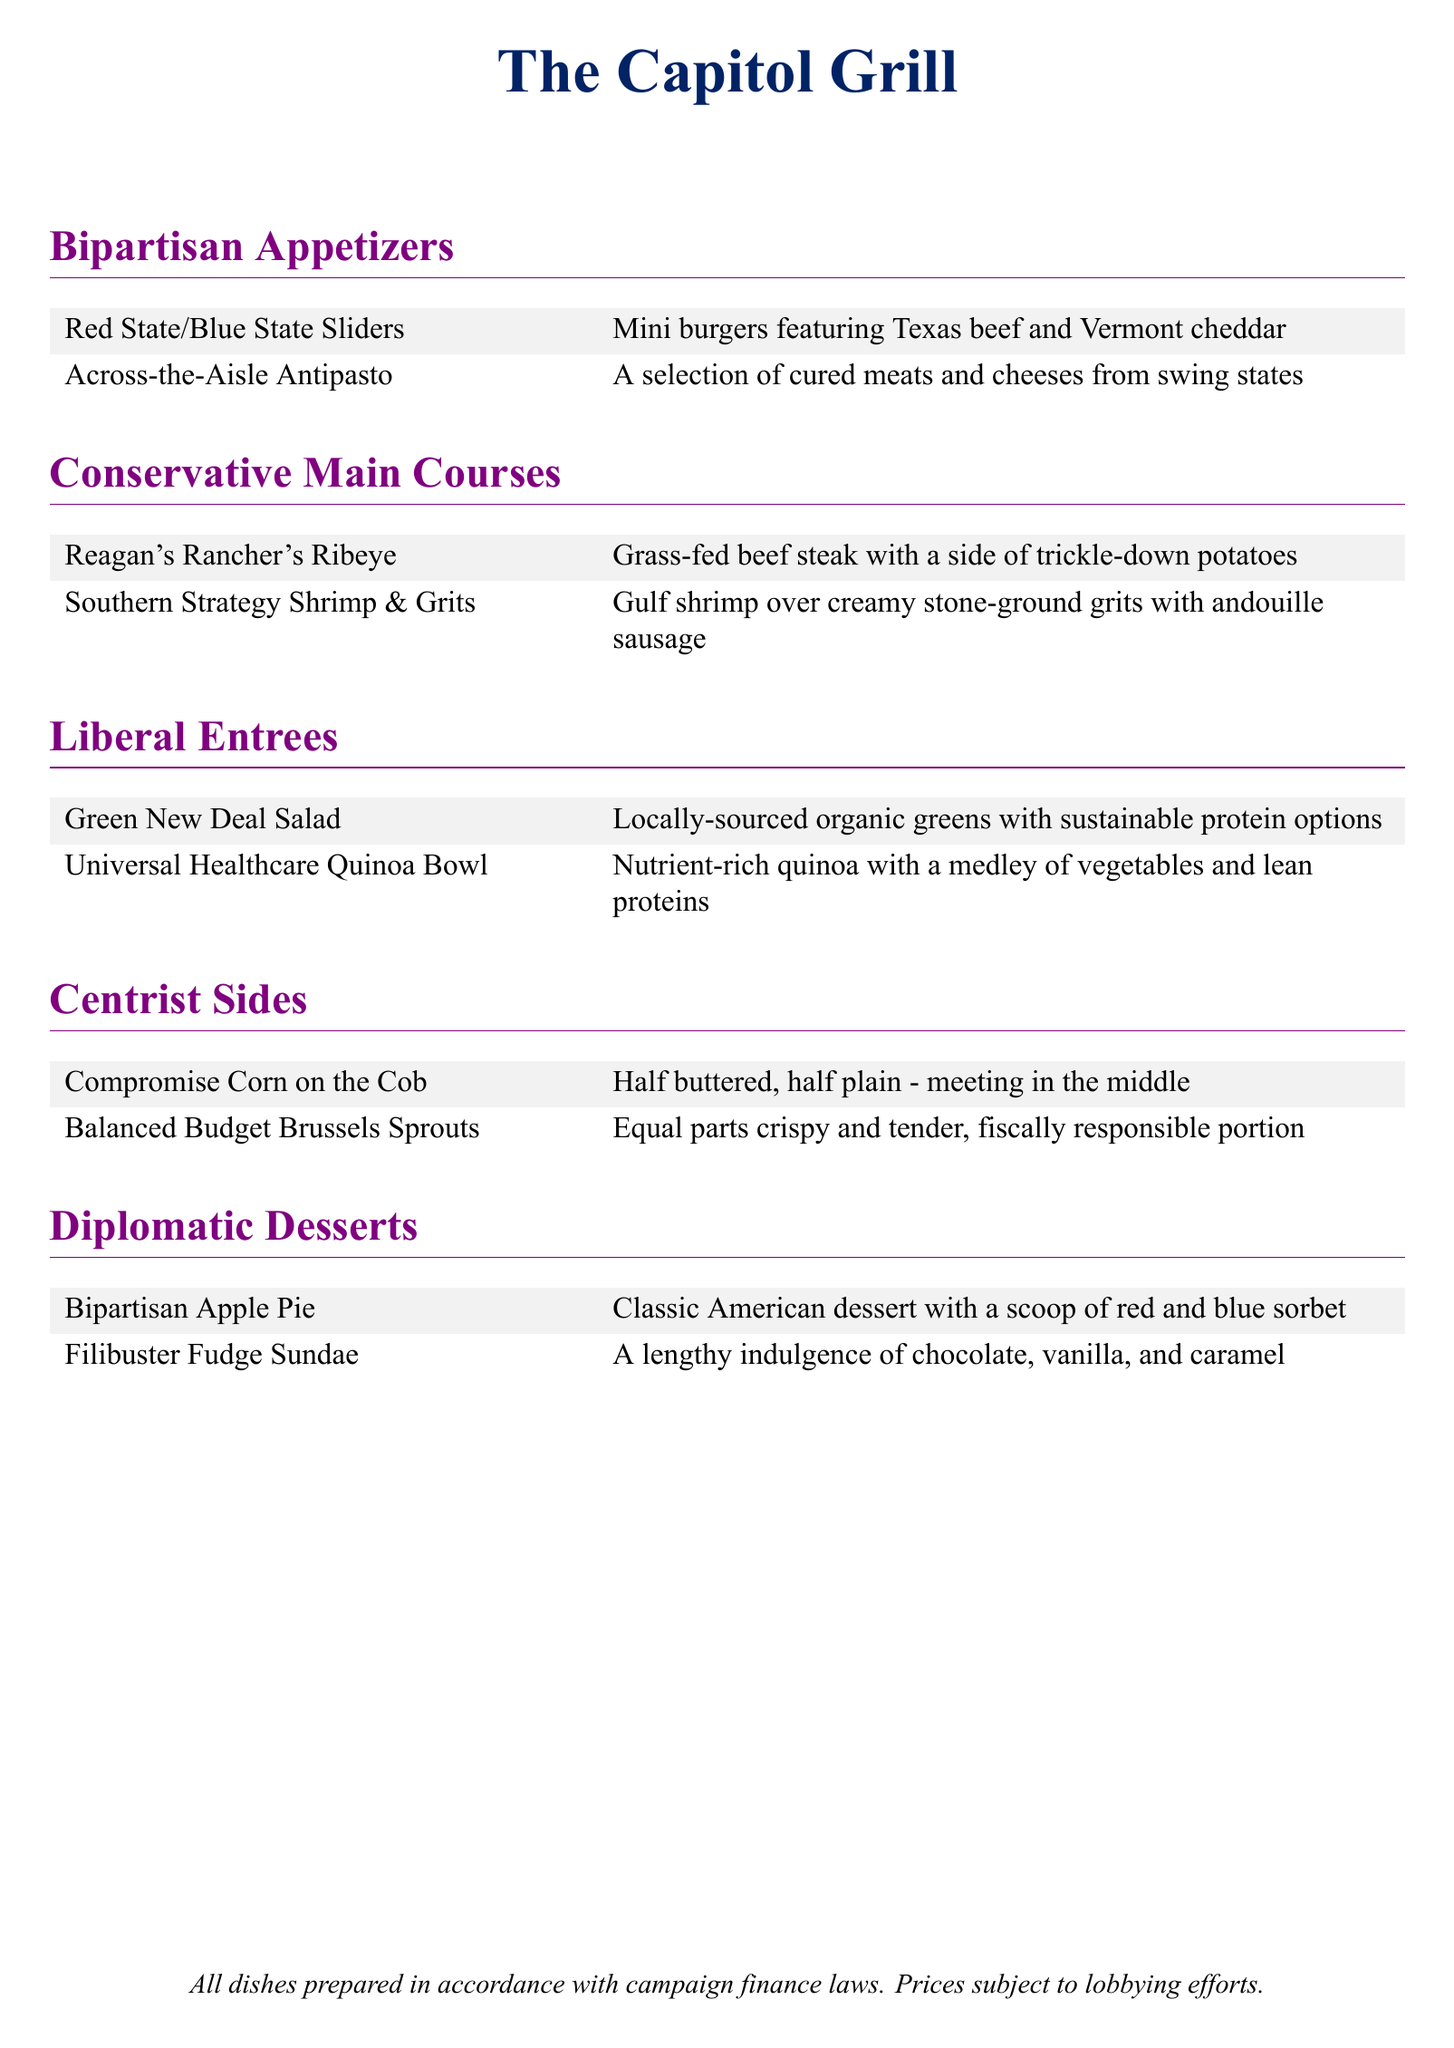What is the name of the restaurant? The name of the restaurant is prominently displayed at the top of the document.
Answer: The Capitol Grill What color represents conservatives in this menu? The document uses colors to distinguish political themes, with blue assigned to conservatives.
Answer: Conservative blue What dish includes locally-sourced organic greens? The specific dish mentioned in the Liberal Entrees section that features organic greens is named in the menu.
Answer: Green New Deal Salad How many desserts are listed on the menu? The total number of dessert options provided in the Diplomatic Desserts section can be counted.
Answer: Two What type of protein is used in the Universal Healthcare Quinoa Bowl? The dish description indicates the type of protein included in this entrée.
Answer: Lean proteins Which appetizer features cured meats and cheeses? One appetizer is specifically described as containing these items in the Bipartisan Appetizers section.
Answer: Across-the-Aisle Antipasto What is the side dish that meets in the middle? The menu describes this side dish's nature of compromise related to its preparation style.
Answer: Compromise Corn on the Cob What type of dish is the Reagan's Rancher's Ribeye? The main course category indicates the type of dish this item belongs to.
Answer: Grass-fed beef steak What flavor combination is included in the Filibuster Fudge Sundae? The document specifies the ice cream flavors mixed in this dessert.
Answer: Chocolate, vanilla, and caramel 